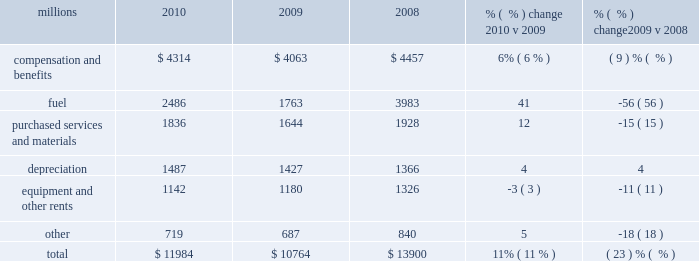Operating expenses millions 2010 2009 2008 % (  % ) change 2010 v 2009 % (  % ) change 2009 v 2008 .
Operating expenses increased $ 1.2 billion in 2010 versus 2009 .
Our fuel price per gallon increased 31% ( 31 % ) during the year , accounting for $ 566 million of the increase .
Wage and benefit inflation , depreciation , volume-related costs , and property taxes also contributed to higher expenses during 2010 compared to 2009 .
Cost savings from productivity improvements and better resource utilization partially offset these increases .
Operating expenses decreased $ 3.1 billion in 2009 versus 2008 .
Our fuel price per gallon declined 44% ( 44 % ) during 2009 , decreasing operating expenses by $ 1.3 billion compared to 2008 .
Cost savings from lower volume , productivity improvements , and better resource utilization also decreased operating expenses in 2009 .
In addition , lower casualty expense resulting primarily from improving trends in safety performance decreased operating expenses in 2009 .
Conversely , wage and benefit inflation partially offset these reductions .
Compensation and benefits 2013 compensation and benefits include wages , payroll taxes , health and welfare costs , pension costs , other postretirement benefits , and incentive costs .
General wage and benefit inflation increased costs by approximately $ 190 million in 2010 compared to 2009 .
Volume- related expenses and higher equity and incentive compensation also drove costs up during the year .
Workforce levels declined 1% ( 1 % ) in 2010 compared to 2009 as network efficiencies and ongoing productivity initiatives enabled us to effectively handle the 13% ( 13 % ) increase in volume levels with fewer employees .
Lower volume and productivity initiatives led to a 10% ( 10 % ) decline in our workforce in 2009 compared to 2008 , saving $ 516 million during the year .
Conversely , general wage and benefit inflation increased expenses , partially offsetting these savings .
Fuel 2013 fuel includes locomotive fuel and gasoline for highway and non-highway vehicles and heavy equipment .
Higher diesel fuel prices , which averaged $ 2.29 per gallon ( including taxes and transportation costs ) in 2010 compared to $ 1.75 per gallon in 2009 , increased expenses by $ 566 million .
Volume , as measured by gross ton-miles , increased 10% ( 10 % ) in 2010 versus 2009 , driving fuel expense up by $ 166 million .
Conversely , the use of newer , more fuel efficient locomotives , our fuel conservation programs and efficient network operations drove a 3% ( 3 % ) improvement in our fuel consumption rate in 2010 , resulting in $ 40 million of cost savings versus 2009 at the 2009 average fuel price .
Lower diesel fuel prices , which averaged $ 1.75 per gallon ( including taxes and transportation costs ) in 2009 compared to $ 3.15 per gallon in 2008 , reduced expenses by $ 1.3 billion in 2009 .
Volume , as measured by gross ton-miles , decreased 17% ( 17 % ) in 2009 , lowering expenses by $ 664 million compared to 2008 .
Our fuel consumption rate improved 4% ( 4 % ) in 2009 , resulting in $ 147 million of cost savings versus 2008 at the 2008 average fuel price .
The consumption rate savings versus 2008 using the lower 2009 fuel price was $ 68 million .
Newer , more fuel efficient locomotives , reflecting locomotive acquisitions in recent years and the impact of a smaller fleet due to storage of some of our older locomotives ; increased use of 2010 operating expenses .
In millions , what is the average operating expenses from 2008-2010? 
Computations: (((11984 + 10764) + 13900) / 3)
Answer: 12216.0. 